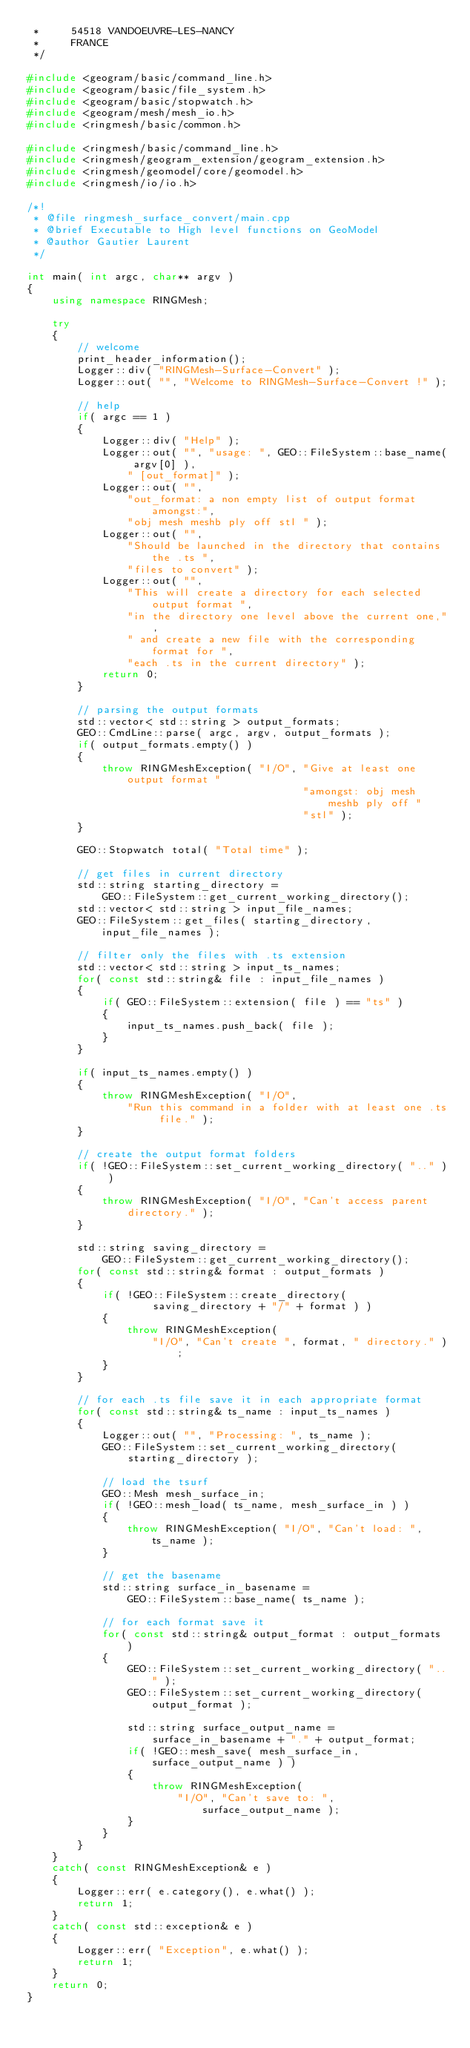<code> <loc_0><loc_0><loc_500><loc_500><_C++_> *     54518 VANDOEUVRE-LES-NANCY
 *     FRANCE
 */

#include <geogram/basic/command_line.h>
#include <geogram/basic/file_system.h>
#include <geogram/basic/stopwatch.h>
#include <geogram/mesh/mesh_io.h>
#include <ringmesh/basic/common.h>

#include <ringmesh/basic/command_line.h>
#include <ringmesh/geogram_extension/geogram_extension.h>
#include <ringmesh/geomodel/core/geomodel.h>
#include <ringmesh/io/io.h>

/*!
 * @file ringmesh_surface_convert/main.cpp
 * @brief Executable to High level functions on GeoModel
 * @author Gautier Laurent
 */

int main( int argc, char** argv )
{
    using namespace RINGMesh;

    try
    {
        // welcome
        print_header_information();
        Logger::div( "RINGMesh-Surface-Convert" );
        Logger::out( "", "Welcome to RINGMesh-Surface-Convert !" );

        // help
        if( argc == 1 )
        {
            Logger::div( "Help" );
            Logger::out( "", "usage: ", GEO::FileSystem::base_name( argv[0] ),
                " [out_format]" );
            Logger::out( "",
                "out_format: a non empty list of output format amongst:",
                "obj mesh meshb ply off stl " );
            Logger::out( "",
                "Should be launched in the directory that contains the .ts ",
                "files to convert" );
            Logger::out( "",
                "This will create a directory for each selected output format ",
                "in the directory one level above the current one,",
                " and create a new file with the corresponding format for ",
                "each .ts in the current directory" );
            return 0;
        }

        // parsing the output formats
        std::vector< std::string > output_formats;
        GEO::CmdLine::parse( argc, argv, output_formats );
        if( output_formats.empty() )
        {
            throw RINGMeshException( "I/O", "Give at least one output format "
                                            "amongst: obj mesh meshb ply off "
                                            "stl" );
        }

        GEO::Stopwatch total( "Total time" );

        // get files in current directory
        std::string starting_directory =
            GEO::FileSystem::get_current_working_directory();
        std::vector< std::string > input_file_names;
        GEO::FileSystem::get_files( starting_directory, input_file_names );

        // filter only the files with .ts extension
        std::vector< std::string > input_ts_names;
        for( const std::string& file : input_file_names )
        {
            if( GEO::FileSystem::extension( file ) == "ts" )
            {
                input_ts_names.push_back( file );
            }
        }

        if( input_ts_names.empty() )
        {
            throw RINGMeshException( "I/O",
                "Run this command in a folder with at least one .ts file." );
        }

        // create the output format folders
        if( !GEO::FileSystem::set_current_working_directory( ".." ) )
        {
            throw RINGMeshException( "I/O", "Can't access parent directory." );
        }

        std::string saving_directory =
            GEO::FileSystem::get_current_working_directory();
        for( const std::string& format : output_formats )
        {
            if( !GEO::FileSystem::create_directory(
                    saving_directory + "/" + format ) )
            {
                throw RINGMeshException(
                    "I/O", "Can't create ", format, " directory." );
            }
        }

        // for each .ts file save it in each appropriate format
        for( const std::string& ts_name : input_ts_names )
        {
            Logger::out( "", "Processing: ", ts_name );
            GEO::FileSystem::set_current_working_directory(
                starting_directory );

            // load the tsurf
            GEO::Mesh mesh_surface_in;
            if( !GEO::mesh_load( ts_name, mesh_surface_in ) )
            {
                throw RINGMeshException( "I/O", "Can't load: ", ts_name );
            }

            // get the basename
            std::string surface_in_basename =
                GEO::FileSystem::base_name( ts_name );

            // for each format save it
            for( const std::string& output_format : output_formats )
            {
                GEO::FileSystem::set_current_working_directory( ".." );
                GEO::FileSystem::set_current_working_directory( output_format );

                std::string surface_output_name =
                    surface_in_basename + "." + output_format;
                if( !GEO::mesh_save( mesh_surface_in, surface_output_name ) )
                {
                    throw RINGMeshException(
                        "I/O", "Can't save to: ", surface_output_name );
                }
            }
        }
    }
    catch( const RINGMeshException& e )
    {
        Logger::err( e.category(), e.what() );
        return 1;
    }
    catch( const std::exception& e )
    {
        Logger::err( "Exception", e.what() );
        return 1;
    }
    return 0;
}
</code> 